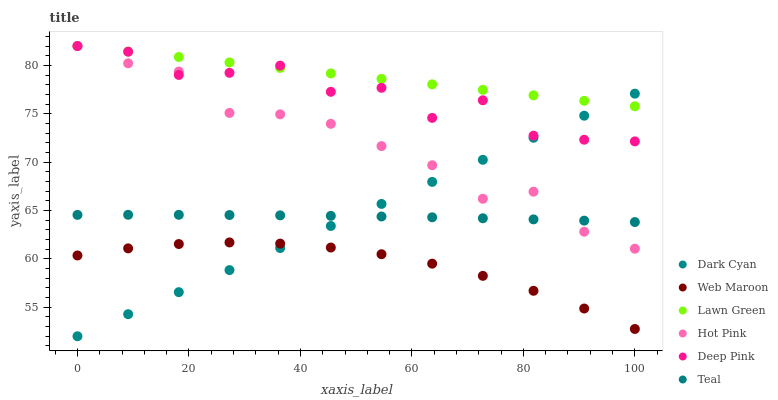Does Web Maroon have the minimum area under the curve?
Answer yes or no. Yes. Does Lawn Green have the maximum area under the curve?
Answer yes or no. Yes. Does Deep Pink have the minimum area under the curve?
Answer yes or no. No. Does Deep Pink have the maximum area under the curve?
Answer yes or no. No. Is Dark Cyan the smoothest?
Answer yes or no. Yes. Is Deep Pink the roughest?
Answer yes or no. Yes. Is Hot Pink the smoothest?
Answer yes or no. No. Is Hot Pink the roughest?
Answer yes or no. No. Does Dark Cyan have the lowest value?
Answer yes or no. Yes. Does Deep Pink have the lowest value?
Answer yes or no. No. Does Hot Pink have the highest value?
Answer yes or no. Yes. Does Web Maroon have the highest value?
Answer yes or no. No. Is Teal less than Lawn Green?
Answer yes or no. Yes. Is Teal greater than Web Maroon?
Answer yes or no. Yes. Does Deep Pink intersect Lawn Green?
Answer yes or no. Yes. Is Deep Pink less than Lawn Green?
Answer yes or no. No. Is Deep Pink greater than Lawn Green?
Answer yes or no. No. Does Teal intersect Lawn Green?
Answer yes or no. No. 